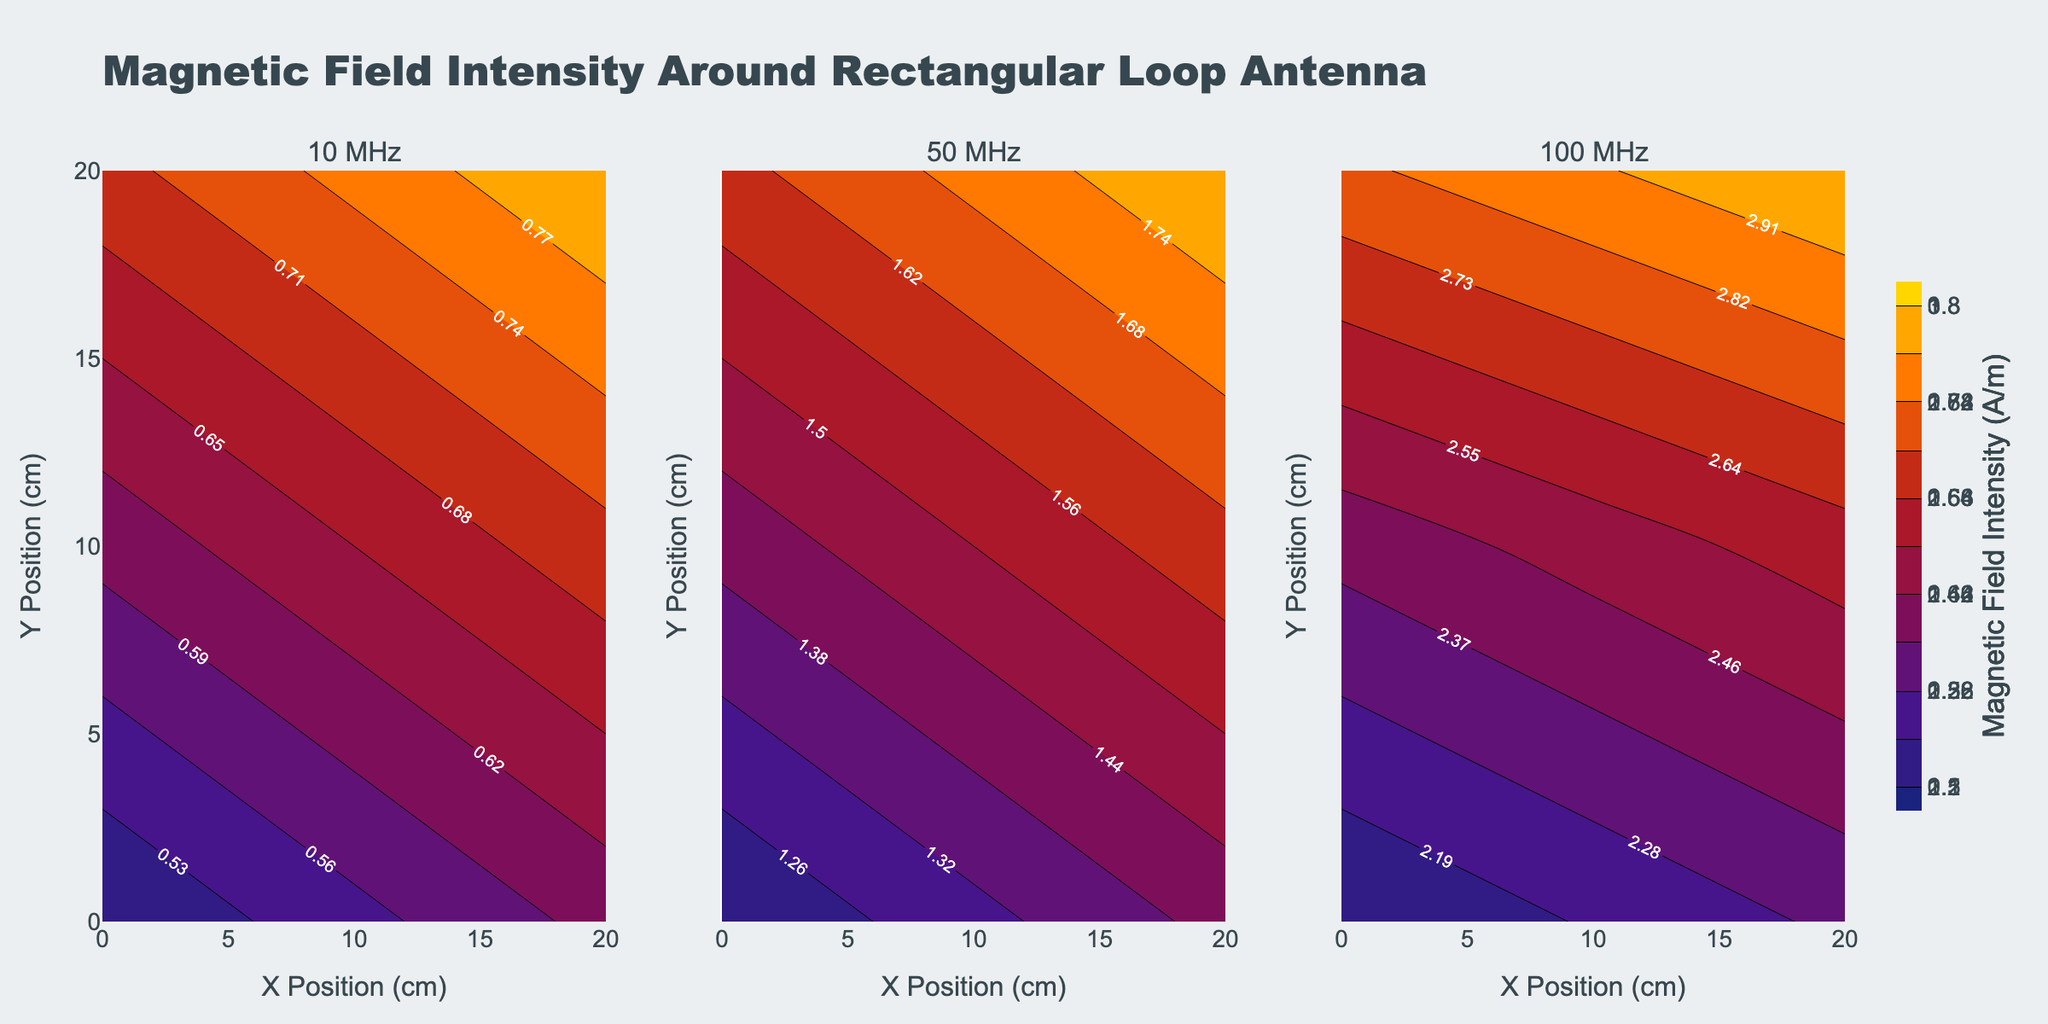What's the title of the plot? The title of the plot is displayed prominently at the top of the figure. It reads 'Magnetic Field Intensity Around Rectangular Loop Antenna'.
Answer: Magnetic Field Intensity Around Rectangular Loop Antenna What are the units of the colorbar? The colorbar, which indicates the magnetic field intensity, has the title showing its units in A/m (Amperes per meter).
Answer: A/m Which frequency range has the highest magnetic field intensity? By comparing the contour levels among the three subplots, the highest magnetic field intensity can be seen in the 100 MHz plot, reaching up to 3.0 A/m.
Answer: 100 MHz What's the range of magnetic field intensity values at 50 MHz? The contour lines for 50 MHz show that magnetic field intensity ranges from 1.2 to 1.8 A/m as indicated by the minimum and maximum values in the colorbar.
Answer: 1.2 to 1.8 A/m How does the field intensity at (10 cm, 20 cm) compare between 10 MHz and 50 MHz? At 10 MHz, the magnetic field intensity at (10 cm, 20 cm) is 0.75 A/m. At 50 MHz, it is 1.7 A/m. 1.7 A/m is greater than 0.75 A/m, meaning it’s much higher at 50 MHz.
Answer: Higher at 50 MHz What are the labels used for the x-axis and y-axis? The x-axis label is 'X Position (cm)', and the y-axis label is 'Y Position (cm)' as shown at the bottom and side of the figure.
Answer: X Position (cm) and Y Position (cm) What is the magnetic field intensity at the origin (0 cm, 0 cm) in the 100 MHz plot? By looking at the contour plot for 100 MHz and checking the contour label at the (0 cm, 0 cm) point, the magnetic field intensity is 2.1 A/m.
Answer: 2.1 A/m Which subplot shows the most variation in magnetic field intensity? By comparing the range and difference in contour lines, the 100 MHz subplot shows the most variation, ranging from 2.1 to 3.0 A/m.
Answer: 100 MHz Is there a point where the field intensity is the same across all frequency ranges? Observing the contour labels, there is no single coordinate point where the magnetic field intensity is the same for 10 MHz, 50 MHz, and 100 MHz plots simultaneously.
Answer: No 